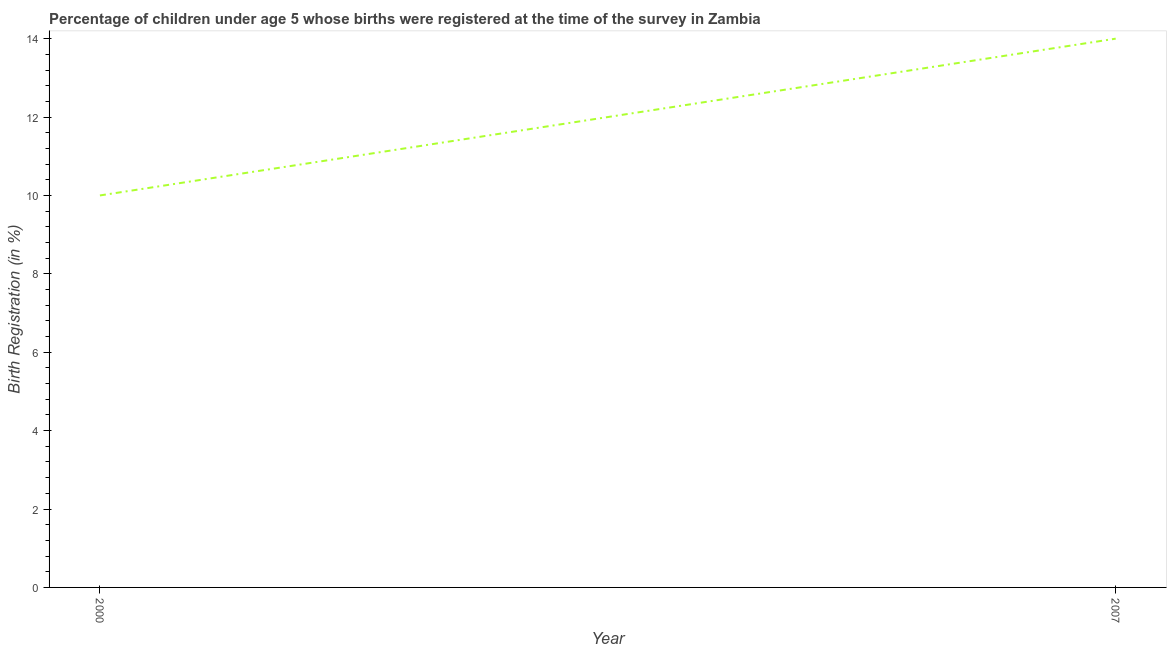What is the birth registration in 2007?
Offer a terse response. 14. Across all years, what is the maximum birth registration?
Keep it short and to the point. 14. Across all years, what is the minimum birth registration?
Your response must be concise. 10. What is the sum of the birth registration?
Your answer should be compact. 24. What is the difference between the birth registration in 2000 and 2007?
Your response must be concise. -4. What is the average birth registration per year?
Keep it short and to the point. 12. What is the ratio of the birth registration in 2000 to that in 2007?
Make the answer very short. 0.71. Is the birth registration in 2000 less than that in 2007?
Offer a very short reply. Yes. How many years are there in the graph?
Keep it short and to the point. 2. What is the difference between two consecutive major ticks on the Y-axis?
Give a very brief answer. 2. Are the values on the major ticks of Y-axis written in scientific E-notation?
Offer a very short reply. No. Does the graph contain grids?
Offer a terse response. No. What is the title of the graph?
Offer a terse response. Percentage of children under age 5 whose births were registered at the time of the survey in Zambia. What is the label or title of the X-axis?
Give a very brief answer. Year. What is the label or title of the Y-axis?
Make the answer very short. Birth Registration (in %). What is the Birth Registration (in %) in 2007?
Keep it short and to the point. 14. What is the difference between the Birth Registration (in %) in 2000 and 2007?
Offer a terse response. -4. What is the ratio of the Birth Registration (in %) in 2000 to that in 2007?
Ensure brevity in your answer.  0.71. 